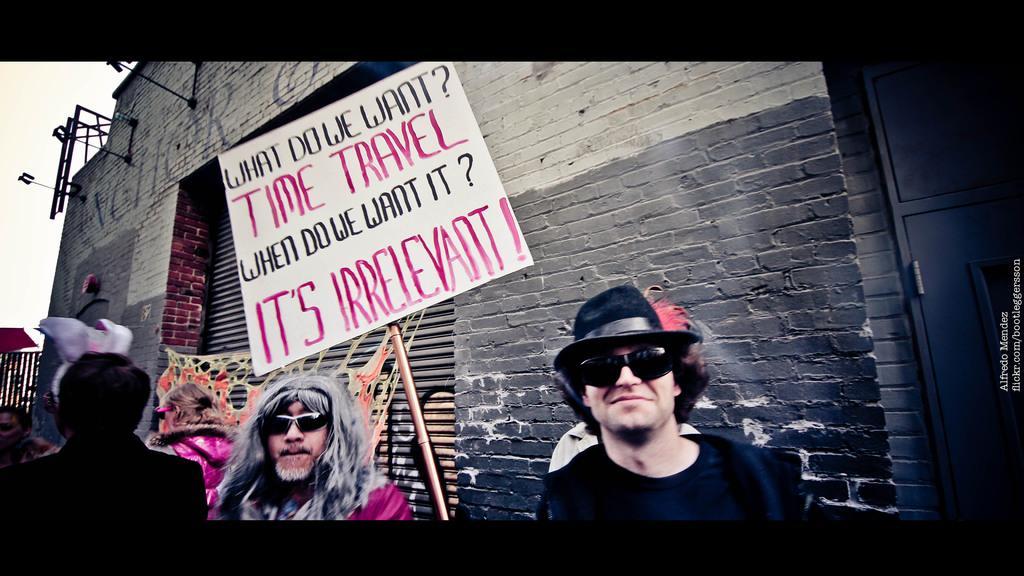Can you describe this image briefly? In this picture we can observe some people standing. There is a white color board fixed to the stick. There is some text on the board. In the background there is a wall and sky. 